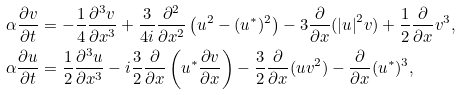Convert formula to latex. <formula><loc_0><loc_0><loc_500><loc_500>\alpha \frac { \partial v } { \partial t } & = - \frac { 1 } { 4 } \frac { \partial ^ { 3 } v } { \partial x ^ { 3 } } + \frac { 3 } { 4 i } \frac { \partial ^ { 2 } } { \partial x ^ { 2 } } \left ( u ^ { 2 } - ( u ^ { * } ) ^ { 2 } \right ) - 3 \frac { \partial } { \partial x } ( { | u | } ^ { 2 } v ) + \frac { 1 } { 2 } \frac { \partial } { \partial x } v ^ { 3 } , \\ \alpha \frac { \partial u } { \partial t } & = \frac { 1 } { 2 } \frac { \partial ^ { 3 } u } { \partial x ^ { 3 } } - i \frac { 3 } { 2 } \frac { \partial } { \partial x } \left ( u ^ { * } \frac { \partial v } { \partial x } \right ) - \frac { 3 } { 2 } \frac { \partial } { \partial x } ( u v ^ { 2 } ) - \frac { \partial } { \partial x } ( u ^ { * } ) ^ { 3 } ,</formula> 